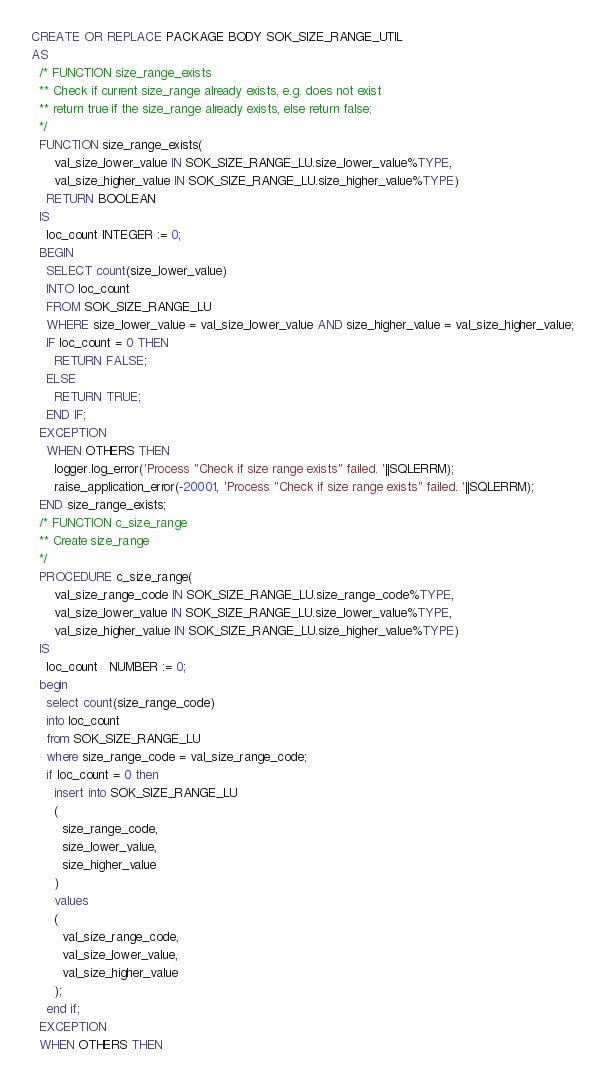Convert code to text. <code><loc_0><loc_0><loc_500><loc_500><_SQL_>CREATE OR REPLACE PACKAGE BODY SOK_SIZE_RANGE_UTIL
AS
  /* FUNCTION size_range_exists
  ** Check if current size_range already exists, e.g. does not exist 
  ** return true if the size_range already exists, else return false;
  */
  FUNCTION size_range_exists(
      val_size_lower_value IN SOK_SIZE_RANGE_LU.size_lower_value%TYPE,
      val_size_higher_value IN SOK_SIZE_RANGE_LU.size_higher_value%TYPE)
    RETURN BOOLEAN
  IS
	loc_count INTEGER := 0;
  BEGIN
    SELECT count(size_lower_value)
    INTO loc_count
    FROM SOK_SIZE_RANGE_LU
    WHERE size_lower_value = val_size_lower_value AND size_higher_value = val_size_higher_value;
    IF loc_count = 0 THEN
      RETURN FALSE;
    ELSE
      RETURN TRUE;
    END IF;
  EXCEPTION
    WHEN OTHERS THEN
      logger.log_error('Process "Check if size range exists" failed. '||SQLERRM);
      raise_application_error(-20001, 'Process "Check if size range exists" failed. '||SQLERRM);
  END size_range_exists;
  /* FUNCTION c_size_range
  ** Create size_range
  */
  PROCEDURE c_size_range(
      val_size_range_code IN SOK_SIZE_RANGE_LU.size_range_code%TYPE,
      val_size_lower_value IN SOK_SIZE_RANGE_LU.size_lower_value%TYPE,
      val_size_higher_value IN SOK_SIZE_RANGE_LU.size_higher_value%TYPE)
  IS
    loc_count   NUMBER := 0;
  begin
    select count(size_range_code)
    into loc_count
    from SOK_SIZE_RANGE_LU
    where size_range_code = val_size_range_code;
    if loc_count = 0 then
      insert into SOK_SIZE_RANGE_LU 
      (
        size_range_code,
        size_lower_value,
        size_higher_value
      )
      values 
      (
        val_size_range_code,
        val_size_lower_value,
        val_size_higher_value
      );
    end if;
  EXCEPTION
  WHEN OTHERS THEN</code> 